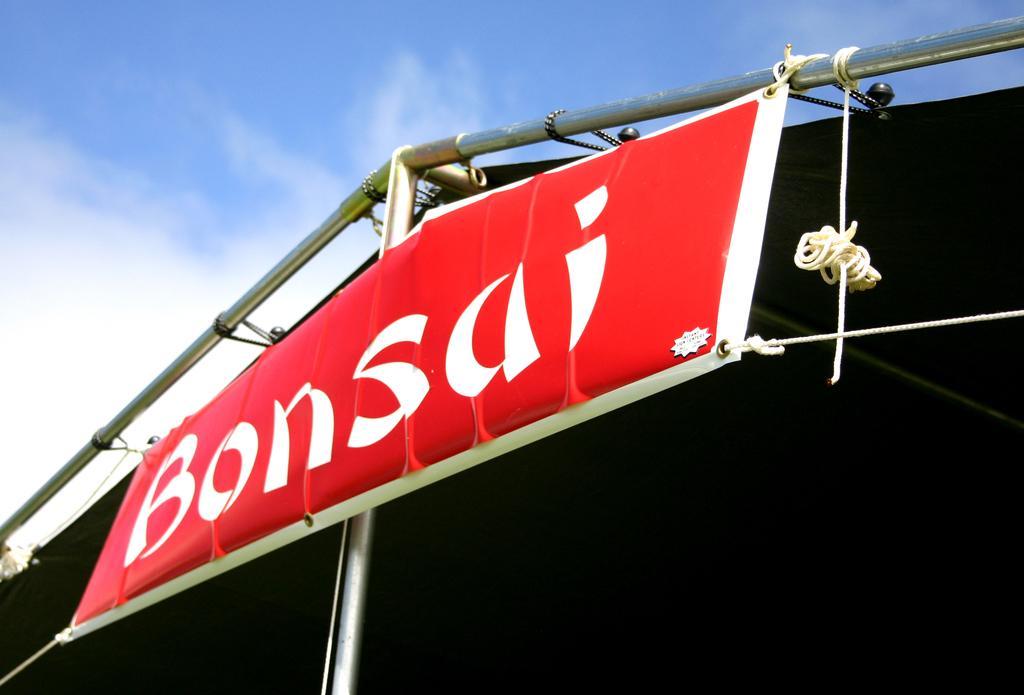Describe this image in one or two sentences. In this image we can see a banner, ropes, rods and other objects. In the background of the image there is a shed and the sky. 